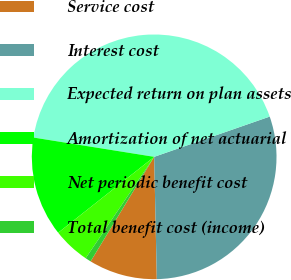<chart> <loc_0><loc_0><loc_500><loc_500><pie_chart><fcel>Service cost<fcel>Interest cost<fcel>Expected return on plan assets<fcel>Amortization of net actuarial<fcel>Net periodic benefit cost<fcel>Total benefit cost (income)<nl><fcel>9.04%<fcel>29.99%<fcel>42.14%<fcel>13.17%<fcel>4.9%<fcel>0.76%<nl></chart> 